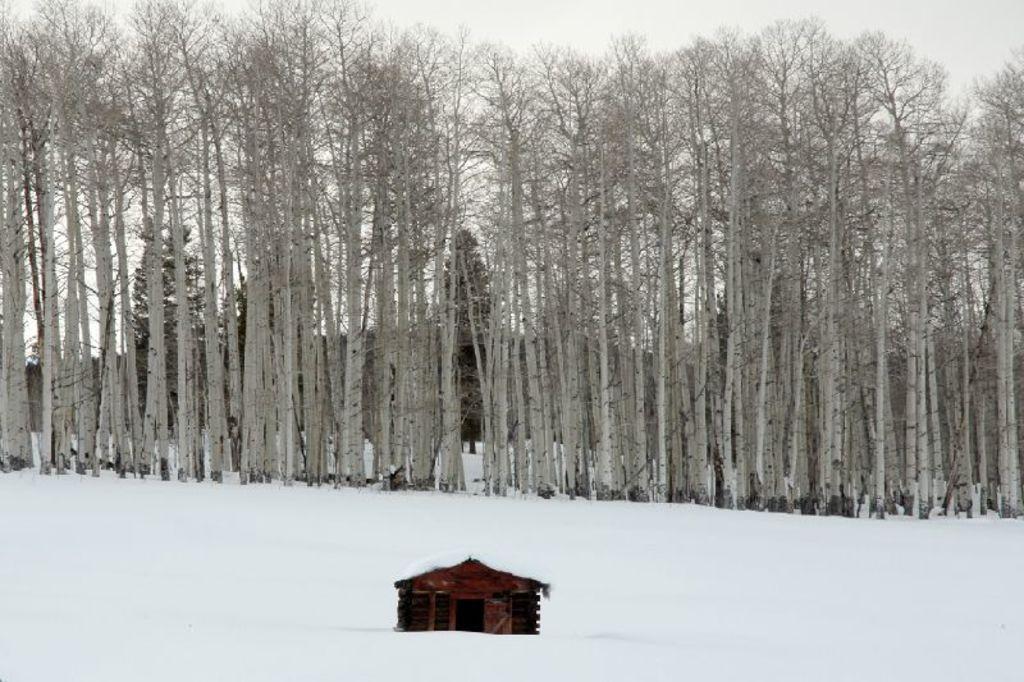Please provide a concise description of this image. In the image there is a home in the front on the snow land with many trees behind it and above its sky. 